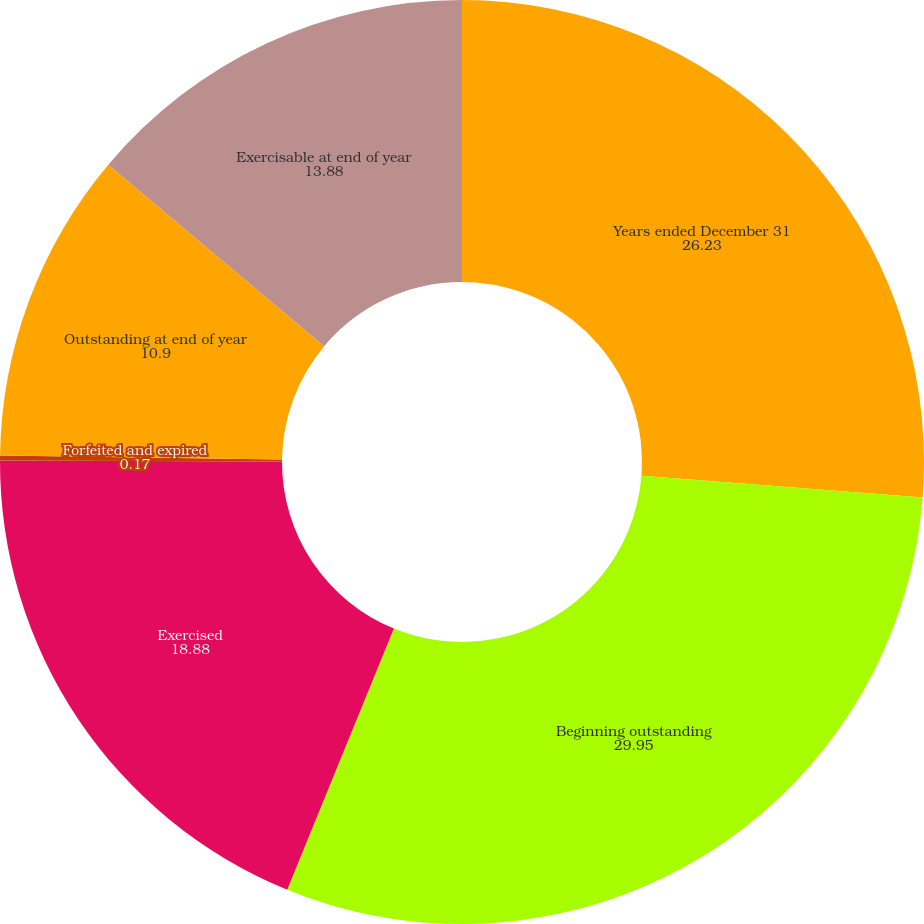Convert chart to OTSL. <chart><loc_0><loc_0><loc_500><loc_500><pie_chart><fcel>Years ended December 31<fcel>Beginning outstanding<fcel>Exercised<fcel>Forfeited and expired<fcel>Outstanding at end of year<fcel>Exercisable at end of year<nl><fcel>26.23%<fcel>29.95%<fcel>18.88%<fcel>0.17%<fcel>10.9%<fcel>13.88%<nl></chart> 